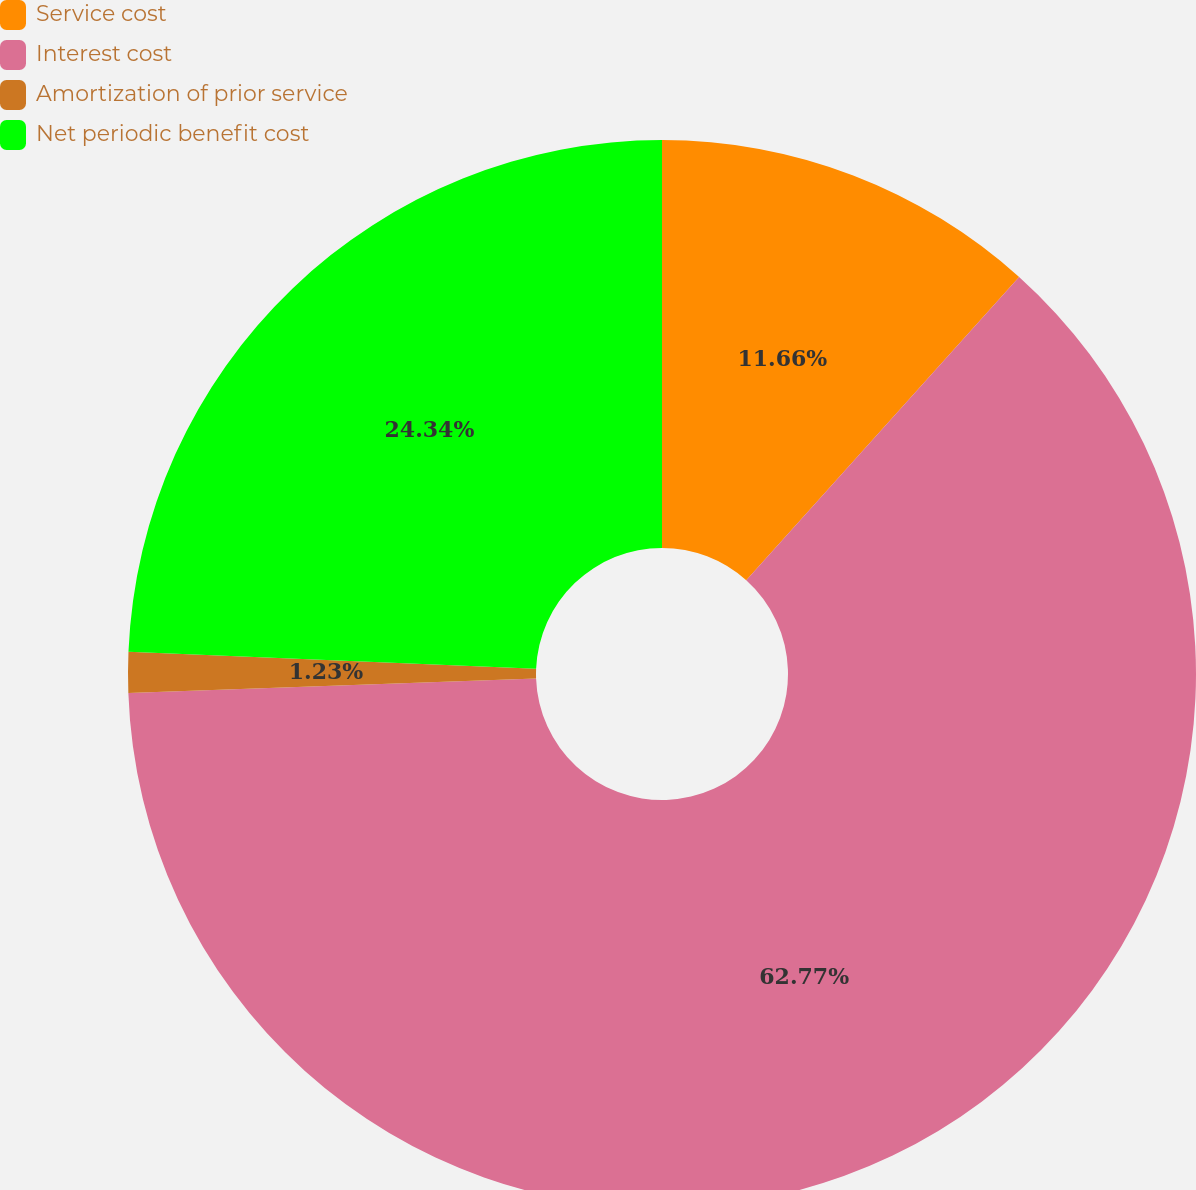Convert chart. <chart><loc_0><loc_0><loc_500><loc_500><pie_chart><fcel>Service cost<fcel>Interest cost<fcel>Amortization of prior service<fcel>Net periodic benefit cost<nl><fcel>11.66%<fcel>62.78%<fcel>1.23%<fcel>24.34%<nl></chart> 